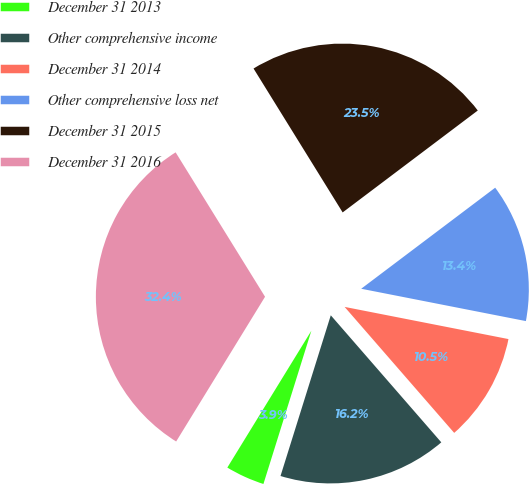<chart> <loc_0><loc_0><loc_500><loc_500><pie_chart><fcel>December 31 2013<fcel>Other comprehensive income<fcel>December 31 2014<fcel>Other comprehensive loss net<fcel>December 31 2015<fcel>December 31 2016<nl><fcel>3.94%<fcel>16.22%<fcel>10.52%<fcel>13.37%<fcel>23.54%<fcel>32.41%<nl></chart> 